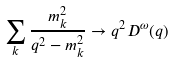Convert formula to latex. <formula><loc_0><loc_0><loc_500><loc_500>\sum _ { k } \frac { m _ { k } ^ { 2 } } { q ^ { 2 } - m _ { k } ^ { 2 } } \rightarrow q ^ { 2 } D ^ { \omega } ( q )</formula> 